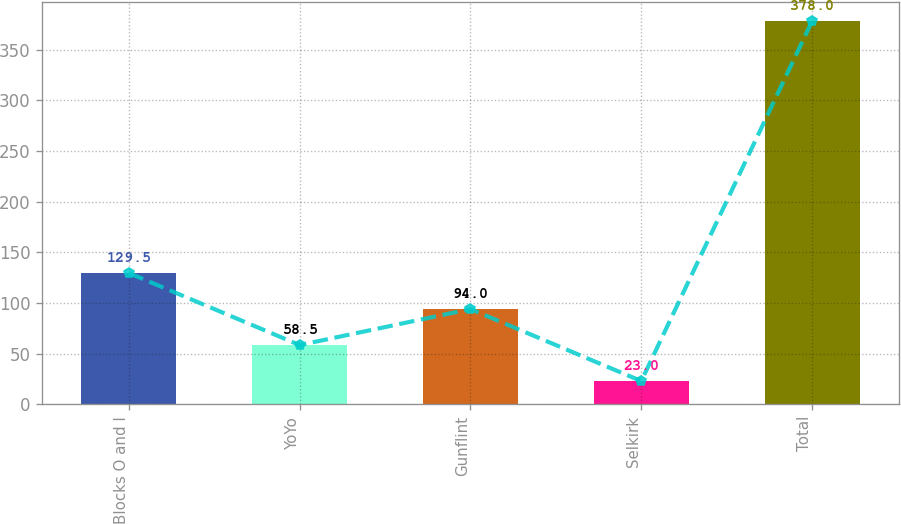Convert chart. <chart><loc_0><loc_0><loc_500><loc_500><bar_chart><fcel>Blocks O and I<fcel>YoYo<fcel>Gunflint<fcel>Selkirk<fcel>Total<nl><fcel>129.5<fcel>58.5<fcel>94<fcel>23<fcel>378<nl></chart> 